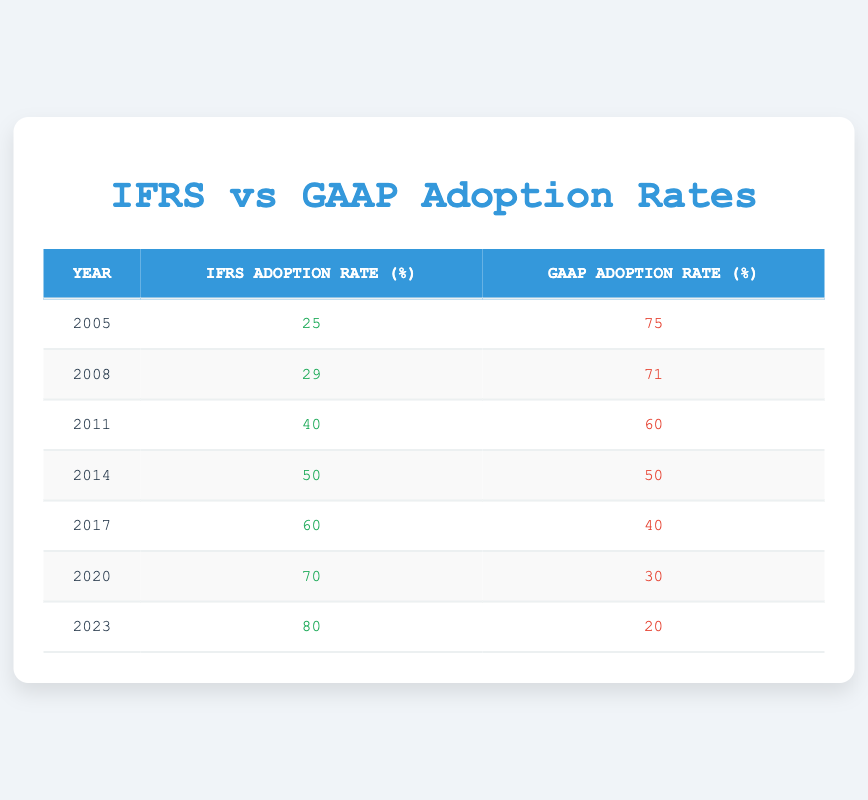What was the IFRS adoption rate in 2014? Looking at the table, the IFRS adoption rate for the year 2014 is listed directly.
Answer: 50 In which year did the GAAP adoption rate fall below 50%? By examining the table, I can see that the GAAP adoption rate fell to 40% in 2017, which is the first instance below 50%.
Answer: 2017 What is the difference between the IFRS adoption rate in 2023 and the rate in 2005? The IFRS adoption rate in 2023 is 80%, and in 2005 it was 25%. The difference is calculated as 80 - 25 = 55.
Answer: 55 What was the average IFRS adoption rate from 2005 to 2023? To find the average, I sum the IFRS rates: 25 + 29 + 40 + 50 + 60 + 70 + 80 = 354. There are 7 years from 2005 to 2023, so the average is 354 / 7 = 50.57.
Answer: 50.57 Did the adoption of IFRS consistently increase from 2005 to 2023? By checking the IFRS adoption rates yearly, I see they went from 25% in 2005 to 80% in 2023, indicating a consistent increase each year.
Answer: Yes What was the total adoption rate for both IFRS and GAAP in 2011? In 2011, the IFRS adoption rate was 40%, and the GAAP adoption rate was 60%. Adding these gives 40 + 60 = 100.
Answer: 100 What percentage of GAAP was adopted in the year 2020 compared to 2011? The GAAP adoption rate in 2020 was 30% and in 2011 it was 60%. The percentage decrease is calculated as (60 - 30) / 60 * 100 = 50%.
Answer: 50% Was the GAAP adoption rate higher than 70% in any of the years listed? By reviewing the table, I see that the GAAP adoption rate was above 70% only in 2005 (75% in 2005 and 71% in 2008). There were no years after 2008 that reached above 70%.
Answer: Yes In which years did the IFRS adoption rate see the largest increase year-over-year? The greatest year-over-year increases were from 2014 to 2017, where it increased from 50% to 60% (10% increase), and from 2011 to 2014, increasing from 40% to 50%, which is also a 10% increase.
Answer: 2014 to 2017 and 2011 to 2014 